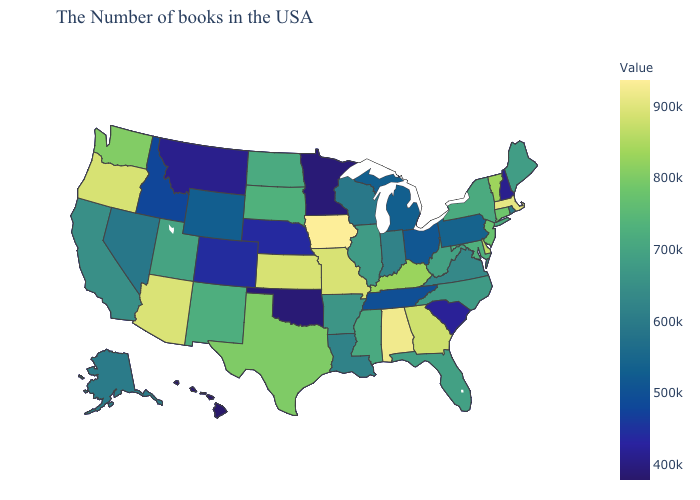Does the map have missing data?
Concise answer only. No. Does North Carolina have a lower value than Vermont?
Write a very short answer. Yes. Does Oregon have a lower value than Colorado?
Concise answer only. No. Among the states that border New York , does Pennsylvania have the lowest value?
Write a very short answer. Yes. Among the states that border Montana , does South Dakota have the highest value?
Keep it brief. Yes. 